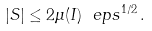<formula> <loc_0><loc_0><loc_500><loc_500>| S | \leq 2 \mu ( I ) \ e p s ^ { 1 / 2 } \, .</formula> 